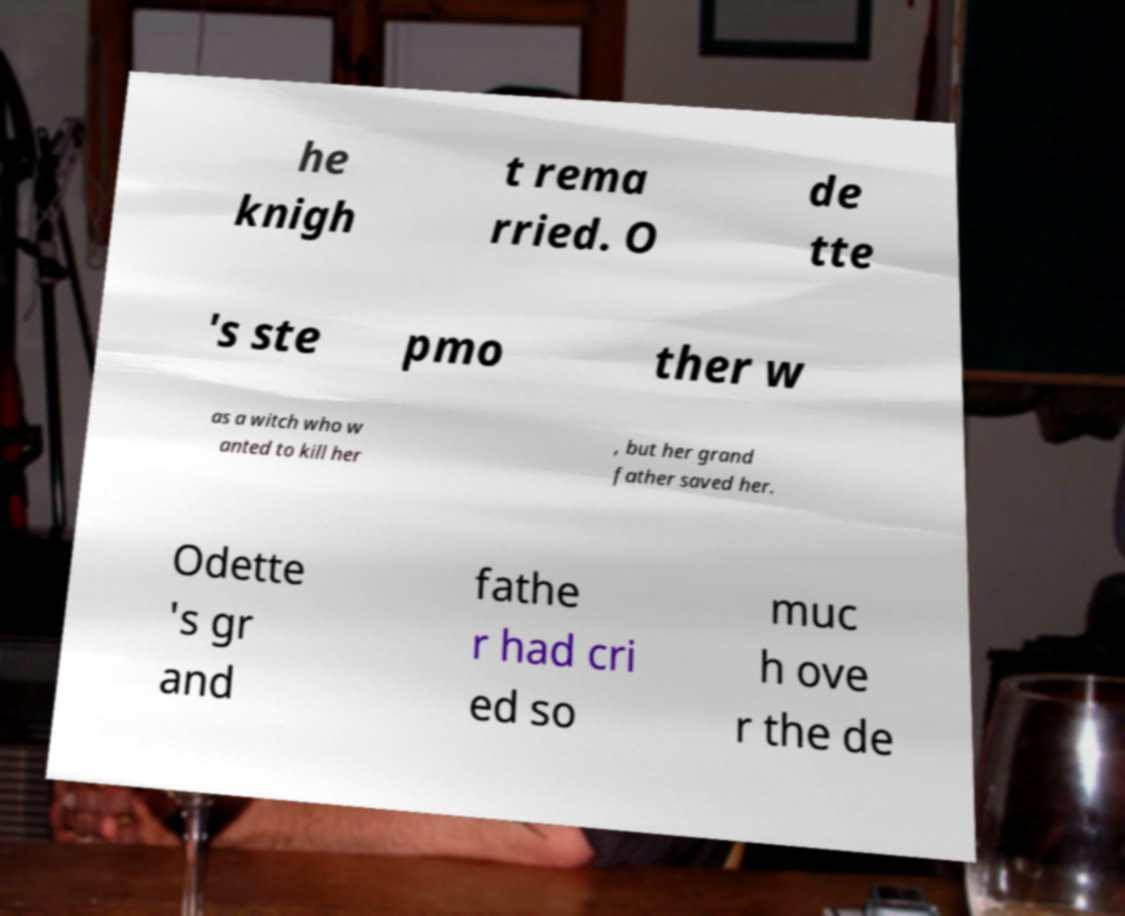Can you read and provide the text displayed in the image?This photo seems to have some interesting text. Can you extract and type it out for me? he knigh t rema rried. O de tte 's ste pmo ther w as a witch who w anted to kill her , but her grand father saved her. Odette 's gr and fathe r had cri ed so muc h ove r the de 